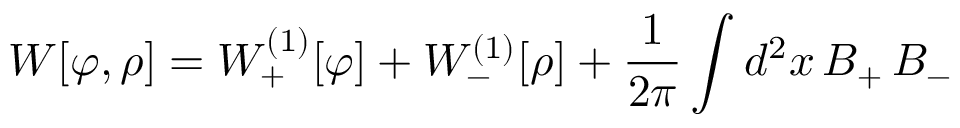<formula> <loc_0><loc_0><loc_500><loc_500>W [ \varphi , \rho ] = W _ { + } ^ { ( 1 ) } [ \varphi ] + W _ { - } ^ { ( 1 ) } [ \rho ] + { \frac { 1 } { 2 \pi } } \int d ^ { 2 } x \, B _ { + } \, B _ { - }</formula> 